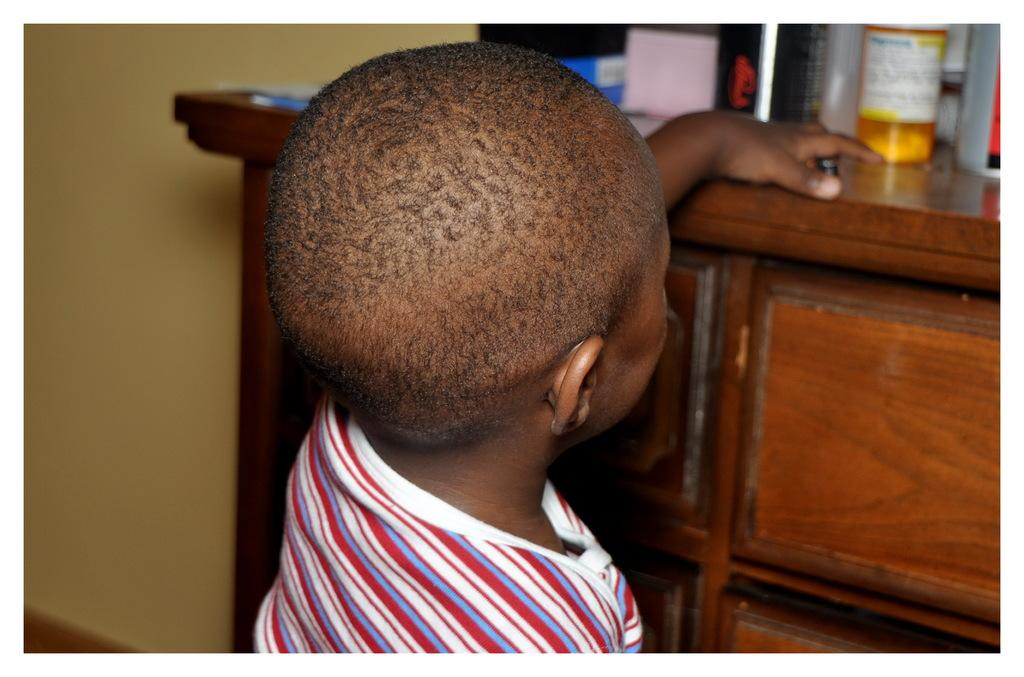What is the main subject of the image? There is a child in the image. What is the child doing in the image? The child is standing. What object is in front of the child? There is a cupboard in the image. What is on top of the cupboard? There are items on top of the cupboard. How does the child sail in the image? The child is not sailing in the image; they are standing in front of a cupboard. What type of twist is the child performing in the image? The child is not performing any twist in the image; they are simply standing. 